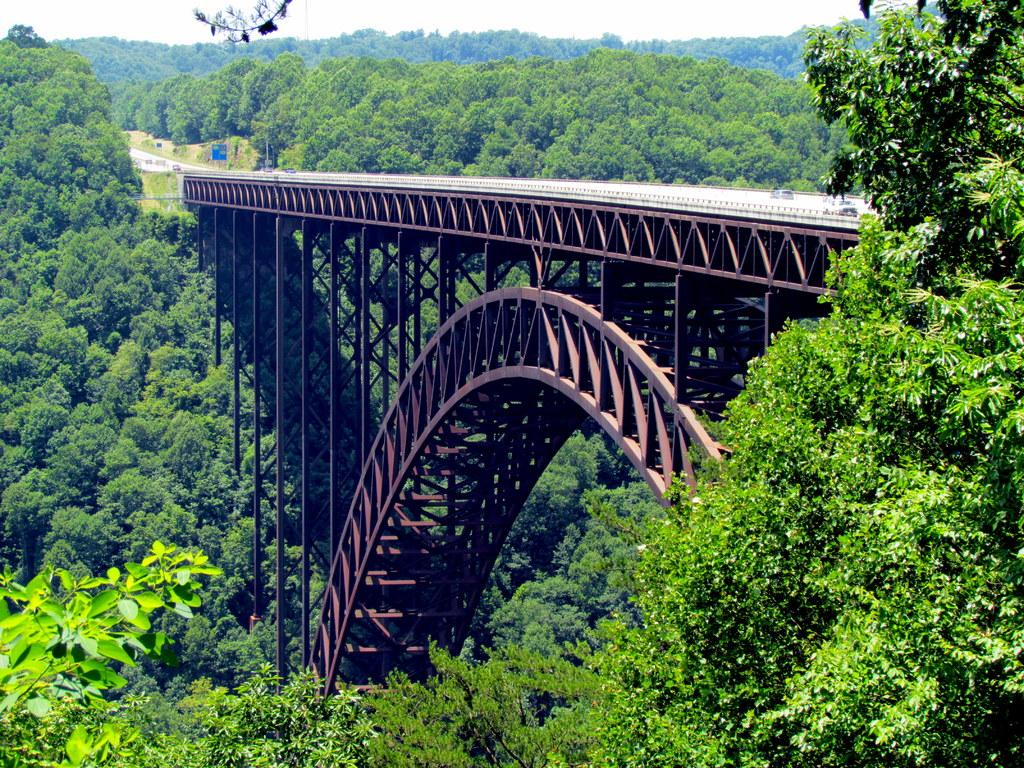What type of structure is present in the image? There is a bridge in the image. What architectural feature can be seen on the bridge? There is an arch in the image. What is happening on the bridge? There are many vehicles on the bridge. What type of natural elements are visible in the image? There are trees visible in the image. What part of the natural environment is visible in the image? The sky is visible in the image. How many tickets are needed to cross the bridge in the image? There is no mention of tickets or any form of payment in the image; it simply shows a bridge with vehicles on it. 